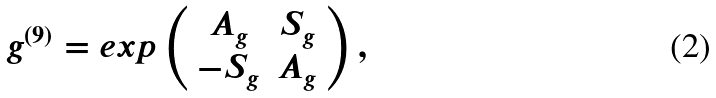Convert formula to latex. <formula><loc_0><loc_0><loc_500><loc_500>g ^ { ( 9 ) } = e x p \left ( \begin{array} { c c } A _ { g } & S _ { g } \\ - S _ { g } & A _ { g } \end{array} \right ) ,</formula> 